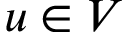Convert formula to latex. <formula><loc_0><loc_0><loc_500><loc_500>u \in V</formula> 